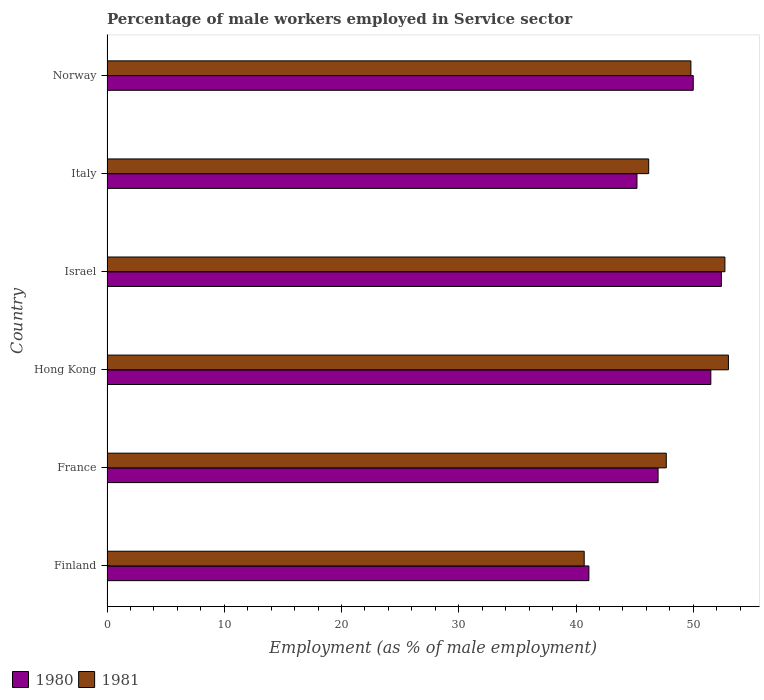How many different coloured bars are there?
Offer a very short reply. 2. How many groups of bars are there?
Your answer should be very brief. 6. Are the number of bars on each tick of the Y-axis equal?
Ensure brevity in your answer.  Yes. How many bars are there on the 6th tick from the top?
Your response must be concise. 2. How many bars are there on the 2nd tick from the bottom?
Ensure brevity in your answer.  2. What is the label of the 6th group of bars from the top?
Your response must be concise. Finland. What is the percentage of male workers employed in Service sector in 1981 in Israel?
Offer a very short reply. 52.7. Across all countries, what is the maximum percentage of male workers employed in Service sector in 1981?
Keep it short and to the point. 53. Across all countries, what is the minimum percentage of male workers employed in Service sector in 1981?
Give a very brief answer. 40.7. In which country was the percentage of male workers employed in Service sector in 1981 maximum?
Ensure brevity in your answer.  Hong Kong. What is the total percentage of male workers employed in Service sector in 1980 in the graph?
Your answer should be compact. 287.2. What is the difference between the percentage of male workers employed in Service sector in 1980 in Israel and that in Norway?
Make the answer very short. 2.4. What is the difference between the percentage of male workers employed in Service sector in 1980 in Finland and the percentage of male workers employed in Service sector in 1981 in Italy?
Ensure brevity in your answer.  -5.1. What is the average percentage of male workers employed in Service sector in 1980 per country?
Provide a succinct answer. 47.87. What is the difference between the percentage of male workers employed in Service sector in 1981 and percentage of male workers employed in Service sector in 1980 in Hong Kong?
Your answer should be very brief. 1.5. What is the ratio of the percentage of male workers employed in Service sector in 1981 in Finland to that in Norway?
Your answer should be compact. 0.82. Is the percentage of male workers employed in Service sector in 1981 in Hong Kong less than that in Italy?
Offer a terse response. No. What is the difference between the highest and the second highest percentage of male workers employed in Service sector in 1980?
Your response must be concise. 0.9. What is the difference between the highest and the lowest percentage of male workers employed in Service sector in 1981?
Offer a terse response. 12.3. What does the 1st bar from the top in Norway represents?
Make the answer very short. 1981. What does the 2nd bar from the bottom in Finland represents?
Offer a terse response. 1981. How many bars are there?
Keep it short and to the point. 12. Are all the bars in the graph horizontal?
Keep it short and to the point. Yes. How many countries are there in the graph?
Keep it short and to the point. 6. What is the difference between two consecutive major ticks on the X-axis?
Keep it short and to the point. 10. Does the graph contain any zero values?
Ensure brevity in your answer.  No. Where does the legend appear in the graph?
Your answer should be very brief. Bottom left. How many legend labels are there?
Provide a short and direct response. 2. What is the title of the graph?
Your answer should be very brief. Percentage of male workers employed in Service sector. Does "1974" appear as one of the legend labels in the graph?
Your answer should be very brief. No. What is the label or title of the X-axis?
Give a very brief answer. Employment (as % of male employment). What is the label or title of the Y-axis?
Your response must be concise. Country. What is the Employment (as % of male employment) of 1980 in Finland?
Ensure brevity in your answer.  41.1. What is the Employment (as % of male employment) in 1981 in Finland?
Provide a short and direct response. 40.7. What is the Employment (as % of male employment) of 1981 in France?
Offer a very short reply. 47.7. What is the Employment (as % of male employment) of 1980 in Hong Kong?
Provide a short and direct response. 51.5. What is the Employment (as % of male employment) of 1980 in Israel?
Make the answer very short. 52.4. What is the Employment (as % of male employment) of 1981 in Israel?
Ensure brevity in your answer.  52.7. What is the Employment (as % of male employment) in 1980 in Italy?
Your response must be concise. 45.2. What is the Employment (as % of male employment) of 1981 in Italy?
Make the answer very short. 46.2. What is the Employment (as % of male employment) in 1981 in Norway?
Your response must be concise. 49.8. Across all countries, what is the maximum Employment (as % of male employment) in 1980?
Offer a very short reply. 52.4. Across all countries, what is the minimum Employment (as % of male employment) in 1980?
Your response must be concise. 41.1. Across all countries, what is the minimum Employment (as % of male employment) in 1981?
Make the answer very short. 40.7. What is the total Employment (as % of male employment) of 1980 in the graph?
Your response must be concise. 287.2. What is the total Employment (as % of male employment) in 1981 in the graph?
Your answer should be compact. 290.1. What is the difference between the Employment (as % of male employment) of 1980 in Finland and that in France?
Your answer should be very brief. -5.9. What is the difference between the Employment (as % of male employment) in 1981 in Finland and that in France?
Provide a succinct answer. -7. What is the difference between the Employment (as % of male employment) of 1980 in Finland and that in Hong Kong?
Keep it short and to the point. -10.4. What is the difference between the Employment (as % of male employment) of 1980 in Finland and that in Israel?
Your answer should be compact. -11.3. What is the difference between the Employment (as % of male employment) in 1980 in Finland and that in Italy?
Your answer should be compact. -4.1. What is the difference between the Employment (as % of male employment) of 1980 in Finland and that in Norway?
Offer a very short reply. -8.9. What is the difference between the Employment (as % of male employment) of 1981 in Finland and that in Norway?
Offer a terse response. -9.1. What is the difference between the Employment (as % of male employment) of 1980 in France and that in Hong Kong?
Keep it short and to the point. -4.5. What is the difference between the Employment (as % of male employment) of 1981 in France and that in Hong Kong?
Your answer should be very brief. -5.3. What is the difference between the Employment (as % of male employment) in 1980 in France and that in Israel?
Provide a succinct answer. -5.4. What is the difference between the Employment (as % of male employment) in 1981 in France and that in Italy?
Offer a very short reply. 1.5. What is the difference between the Employment (as % of male employment) of 1981 in France and that in Norway?
Provide a succinct answer. -2.1. What is the difference between the Employment (as % of male employment) in 1980 in Hong Kong and that in Italy?
Your answer should be compact. 6.3. What is the difference between the Employment (as % of male employment) of 1980 in Hong Kong and that in Norway?
Make the answer very short. 1.5. What is the difference between the Employment (as % of male employment) in 1981 in Hong Kong and that in Norway?
Offer a terse response. 3.2. What is the difference between the Employment (as % of male employment) in 1980 in Israel and that in Italy?
Provide a short and direct response. 7.2. What is the difference between the Employment (as % of male employment) of 1981 in Israel and that in Italy?
Provide a short and direct response. 6.5. What is the difference between the Employment (as % of male employment) of 1980 in Israel and that in Norway?
Your response must be concise. 2.4. What is the difference between the Employment (as % of male employment) of 1980 in Italy and that in Norway?
Provide a short and direct response. -4.8. What is the difference between the Employment (as % of male employment) of 1981 in Italy and that in Norway?
Your answer should be very brief. -3.6. What is the difference between the Employment (as % of male employment) of 1980 in Finland and the Employment (as % of male employment) of 1981 in France?
Provide a short and direct response. -6.6. What is the difference between the Employment (as % of male employment) of 1980 in Finland and the Employment (as % of male employment) of 1981 in Israel?
Provide a short and direct response. -11.6. What is the difference between the Employment (as % of male employment) in 1980 in Finland and the Employment (as % of male employment) in 1981 in Norway?
Your answer should be very brief. -8.7. What is the difference between the Employment (as % of male employment) in 1980 in Hong Kong and the Employment (as % of male employment) in 1981 in Italy?
Your answer should be very brief. 5.3. What is the difference between the Employment (as % of male employment) of 1980 in Israel and the Employment (as % of male employment) of 1981 in Norway?
Your response must be concise. 2.6. What is the average Employment (as % of male employment) of 1980 per country?
Offer a very short reply. 47.87. What is the average Employment (as % of male employment) in 1981 per country?
Make the answer very short. 48.35. What is the difference between the Employment (as % of male employment) in 1980 and Employment (as % of male employment) in 1981 in Finland?
Make the answer very short. 0.4. What is the difference between the Employment (as % of male employment) in 1980 and Employment (as % of male employment) in 1981 in Israel?
Provide a short and direct response. -0.3. What is the ratio of the Employment (as % of male employment) in 1980 in Finland to that in France?
Your answer should be very brief. 0.87. What is the ratio of the Employment (as % of male employment) in 1981 in Finland to that in France?
Keep it short and to the point. 0.85. What is the ratio of the Employment (as % of male employment) of 1980 in Finland to that in Hong Kong?
Provide a short and direct response. 0.8. What is the ratio of the Employment (as % of male employment) of 1981 in Finland to that in Hong Kong?
Your response must be concise. 0.77. What is the ratio of the Employment (as % of male employment) of 1980 in Finland to that in Israel?
Your answer should be compact. 0.78. What is the ratio of the Employment (as % of male employment) in 1981 in Finland to that in Israel?
Offer a very short reply. 0.77. What is the ratio of the Employment (as % of male employment) in 1980 in Finland to that in Italy?
Offer a very short reply. 0.91. What is the ratio of the Employment (as % of male employment) in 1981 in Finland to that in Italy?
Keep it short and to the point. 0.88. What is the ratio of the Employment (as % of male employment) of 1980 in Finland to that in Norway?
Offer a terse response. 0.82. What is the ratio of the Employment (as % of male employment) in 1981 in Finland to that in Norway?
Ensure brevity in your answer.  0.82. What is the ratio of the Employment (as % of male employment) of 1980 in France to that in Hong Kong?
Offer a terse response. 0.91. What is the ratio of the Employment (as % of male employment) of 1981 in France to that in Hong Kong?
Your answer should be very brief. 0.9. What is the ratio of the Employment (as % of male employment) of 1980 in France to that in Israel?
Offer a terse response. 0.9. What is the ratio of the Employment (as % of male employment) of 1981 in France to that in Israel?
Make the answer very short. 0.91. What is the ratio of the Employment (as % of male employment) in 1980 in France to that in Italy?
Provide a short and direct response. 1.04. What is the ratio of the Employment (as % of male employment) in 1981 in France to that in Italy?
Offer a very short reply. 1.03. What is the ratio of the Employment (as % of male employment) in 1981 in France to that in Norway?
Keep it short and to the point. 0.96. What is the ratio of the Employment (as % of male employment) in 1980 in Hong Kong to that in Israel?
Your response must be concise. 0.98. What is the ratio of the Employment (as % of male employment) in 1980 in Hong Kong to that in Italy?
Offer a very short reply. 1.14. What is the ratio of the Employment (as % of male employment) of 1981 in Hong Kong to that in Italy?
Provide a short and direct response. 1.15. What is the ratio of the Employment (as % of male employment) of 1980 in Hong Kong to that in Norway?
Make the answer very short. 1.03. What is the ratio of the Employment (as % of male employment) of 1981 in Hong Kong to that in Norway?
Provide a succinct answer. 1.06. What is the ratio of the Employment (as % of male employment) of 1980 in Israel to that in Italy?
Provide a succinct answer. 1.16. What is the ratio of the Employment (as % of male employment) in 1981 in Israel to that in Italy?
Keep it short and to the point. 1.14. What is the ratio of the Employment (as % of male employment) in 1980 in Israel to that in Norway?
Your answer should be compact. 1.05. What is the ratio of the Employment (as % of male employment) of 1981 in Israel to that in Norway?
Keep it short and to the point. 1.06. What is the ratio of the Employment (as % of male employment) in 1980 in Italy to that in Norway?
Offer a terse response. 0.9. What is the ratio of the Employment (as % of male employment) in 1981 in Italy to that in Norway?
Offer a terse response. 0.93. What is the difference between the highest and the second highest Employment (as % of male employment) of 1980?
Provide a short and direct response. 0.9. What is the difference between the highest and the lowest Employment (as % of male employment) of 1980?
Ensure brevity in your answer.  11.3. 